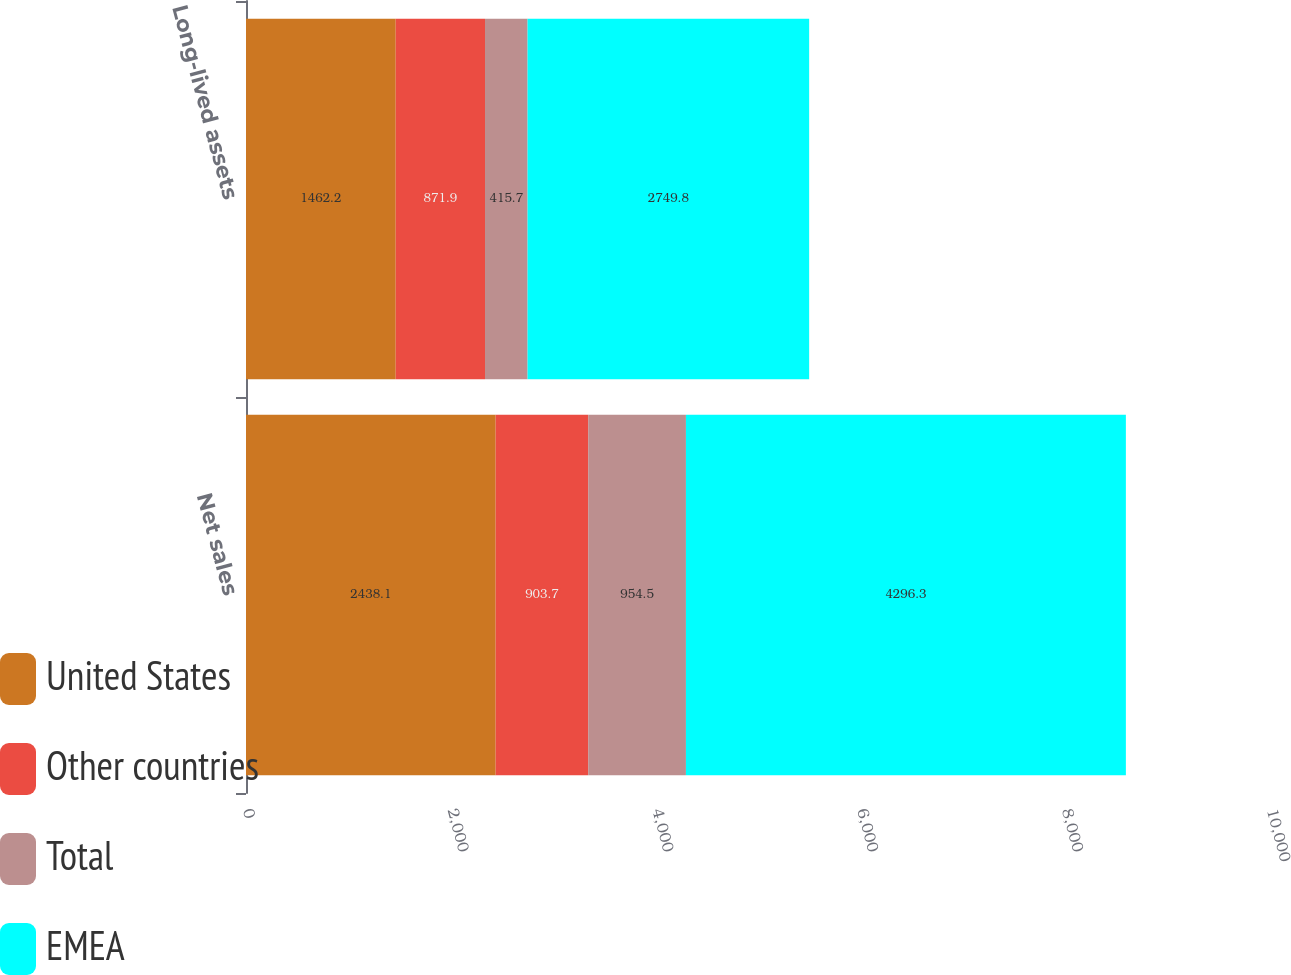<chart> <loc_0><loc_0><loc_500><loc_500><stacked_bar_chart><ecel><fcel>Net sales<fcel>Long-lived assets<nl><fcel>United States<fcel>2438.1<fcel>1462.2<nl><fcel>Other countries<fcel>903.7<fcel>871.9<nl><fcel>Total<fcel>954.5<fcel>415.7<nl><fcel>EMEA<fcel>4296.3<fcel>2749.8<nl></chart> 